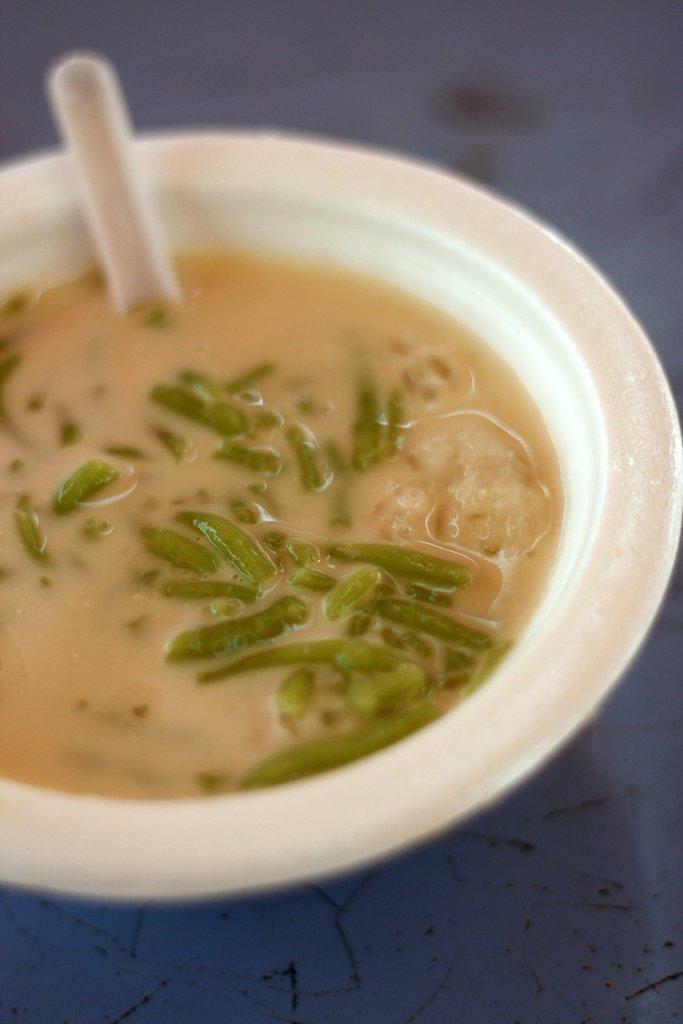Could you give a brief overview of what you see in this image? In this picture there is a bowl of soup in the center of the image and there is a spoon in the bowl. 